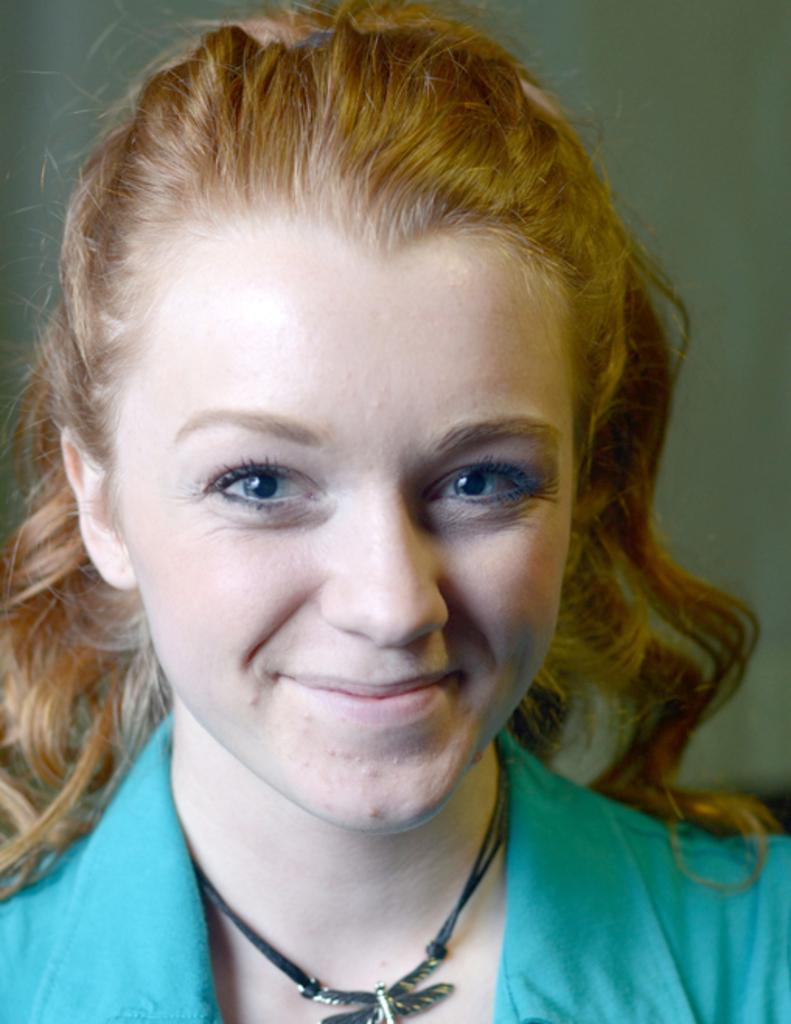Who or what is present in the image? There is a person in the image. What is the person wearing? The person is wearing a blue color shirt. What color is the background of the image? The background of the image is cream color. How many chickens can be seen dancing to the rhythm in the image? There are no chickens or dancing in the image; it features a person wearing a blue shirt against a cream-colored background. 